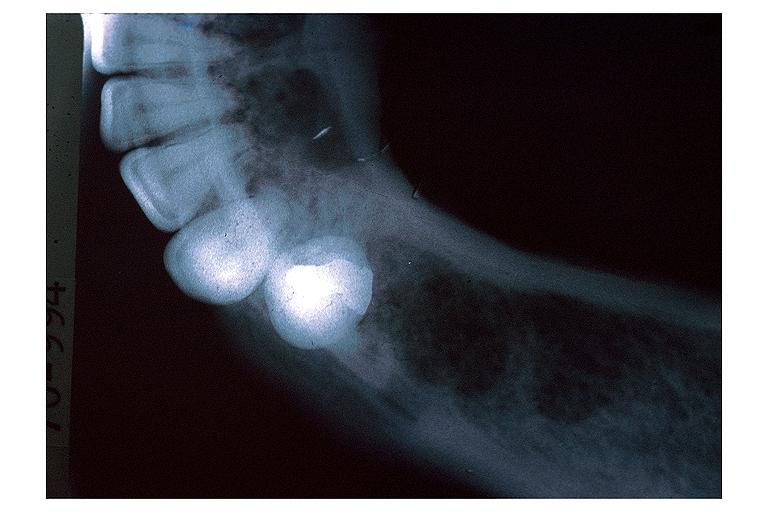where is this?
Answer the question using a single word or phrase. Oral 